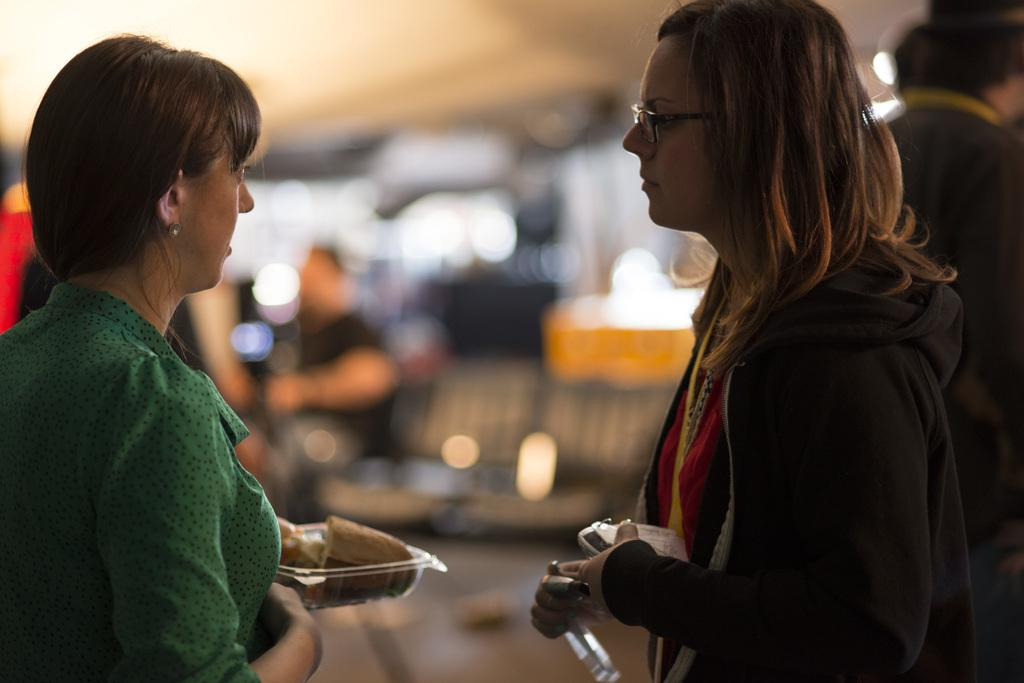How many women are in the image? There are two women in the image. What are the women doing in the image? The women are standing in front of each other. What objects are the women holding? One woman is holding a box, and the other woman is holding a food plate. Can you describe the background of the image? There are people in the background of the image, but they are blurry. What type of locket is the woman wearing around her eye in the image? There is no locket or any jewelry visible around the women's eyes in the image. 